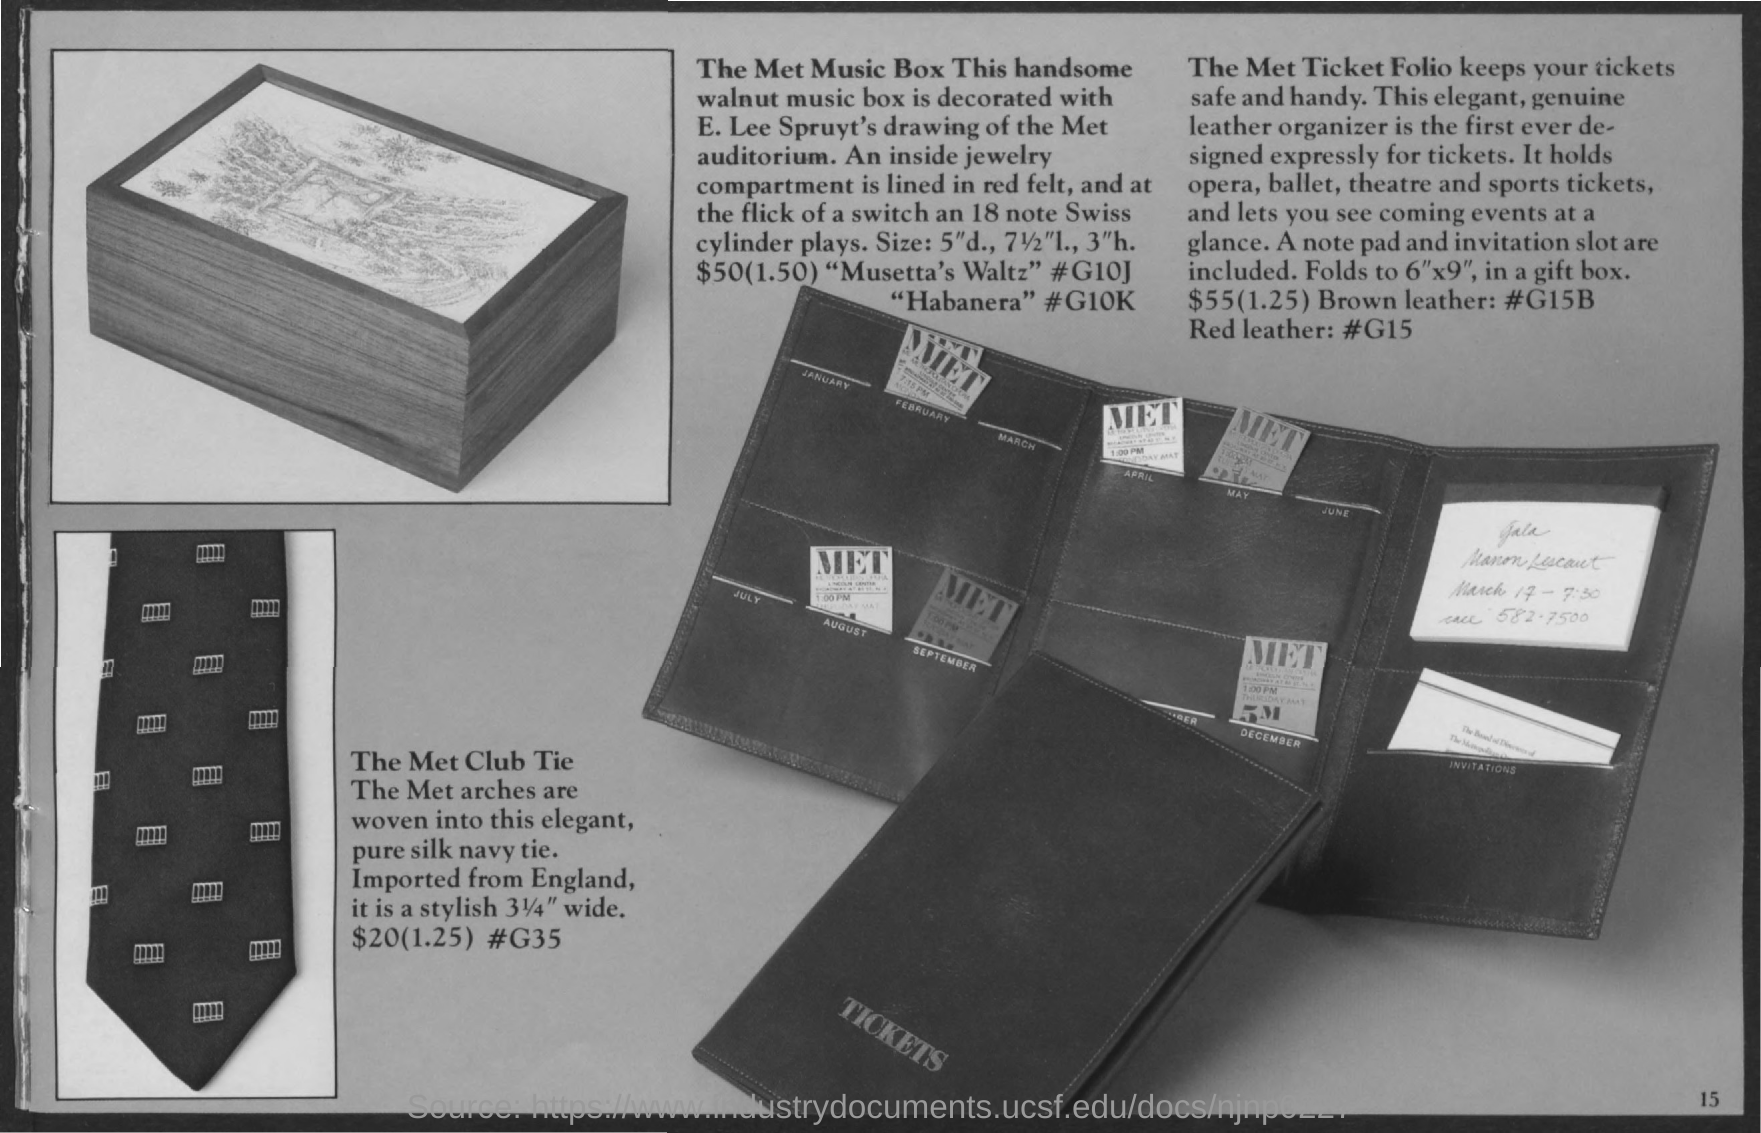The Walnut music box is decorated with whose drawing of the MET auditorium?
Give a very brief answer. E. Lee Spruyt's. What keeps the tickets safe and handy?
Keep it short and to the point. The Met Ticket Folio. 